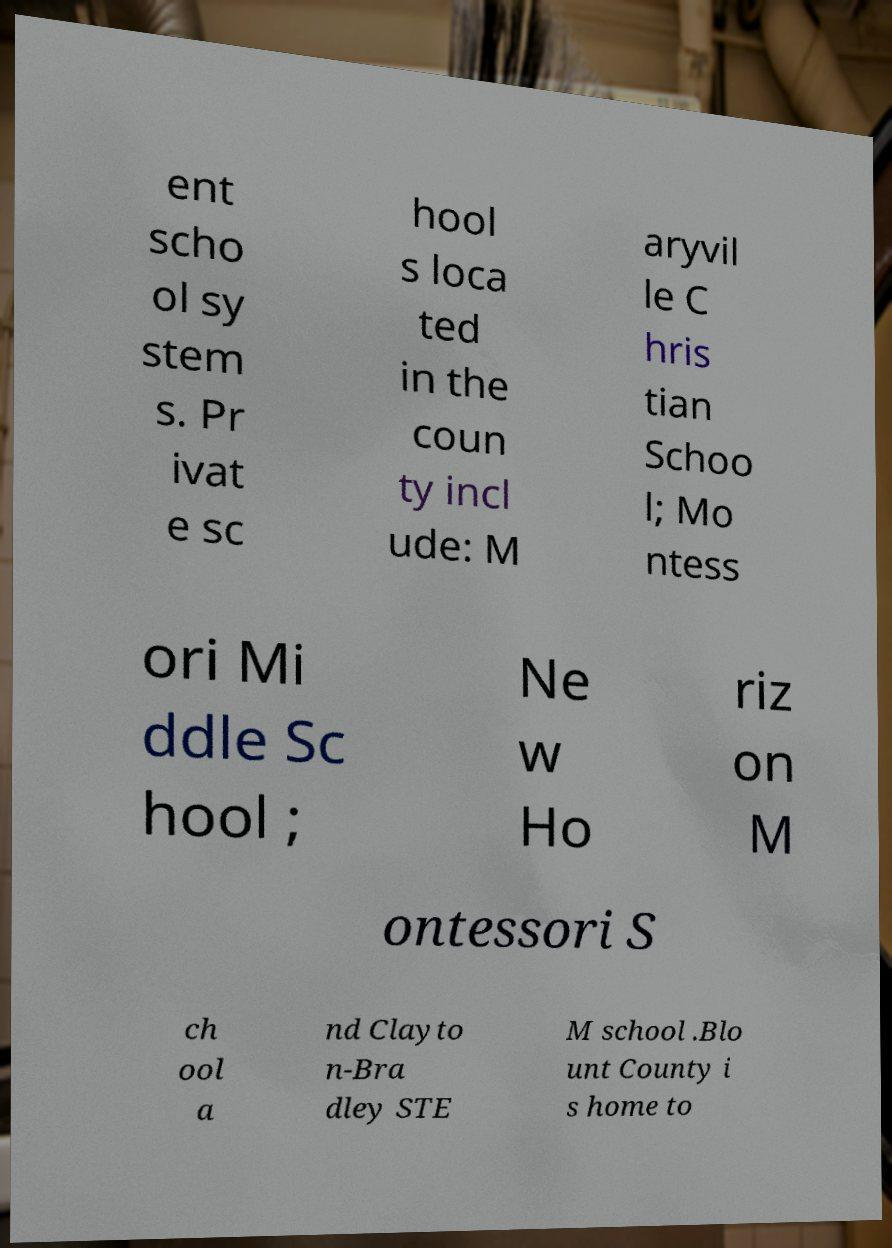For documentation purposes, I need the text within this image transcribed. Could you provide that? ent scho ol sy stem s. Pr ivat e sc hool s loca ted in the coun ty incl ude: M aryvil le C hris tian Schoo l; Mo ntess ori Mi ddle Sc hool ; Ne w Ho riz on M ontessori S ch ool a nd Clayto n-Bra dley STE M school .Blo unt County i s home to 